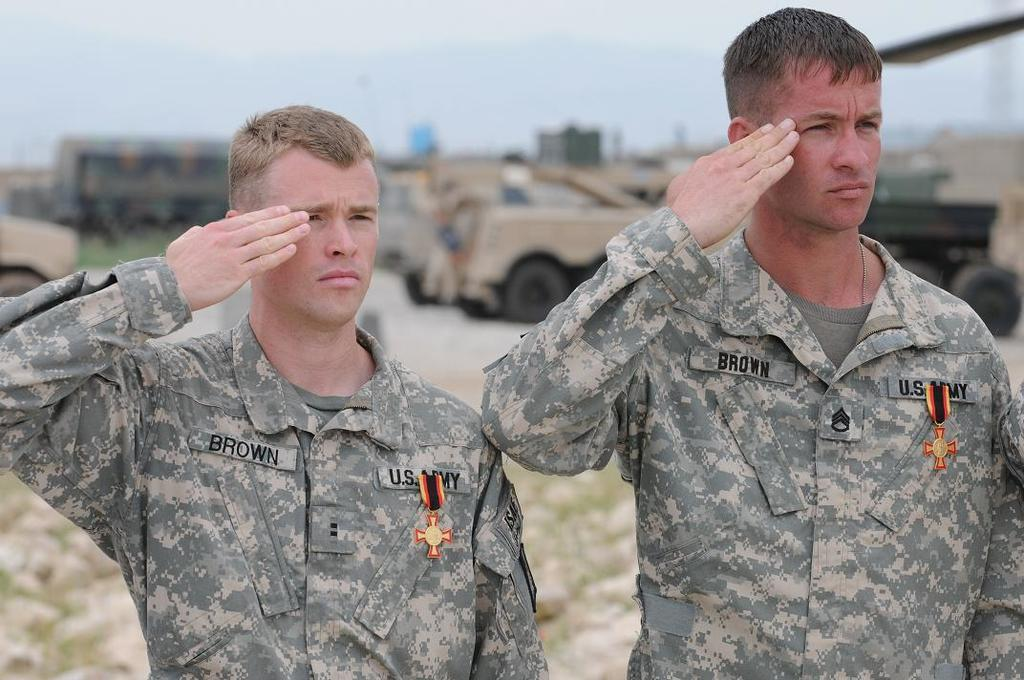How many people are in the image? There are two persons standing in the image. What are the occupations of the people in the image? The two persons are soldiers. What can be seen in the background of the image? There are vehicles in the background of the image. What is visible in the sky in the image? The sky is visible in the image. What type of oven is visible in the image? There is no oven present in the image. How does the company affect the soldiers in the image? There is no mention of a company in the image, so its effect on the soldiers cannot be determined. 